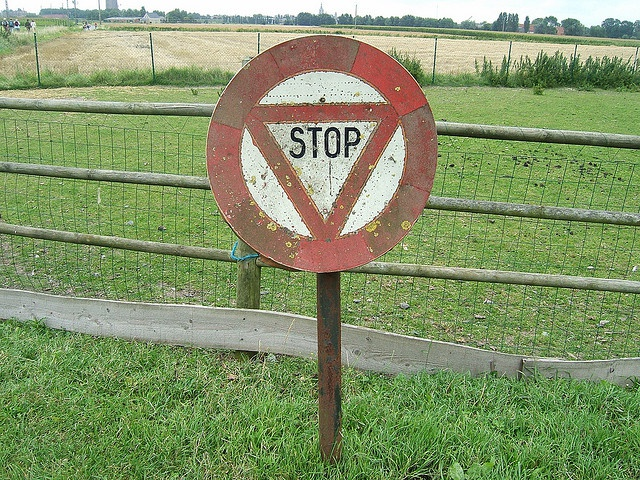Describe the objects in this image and their specific colors. I can see stop sign in white, brown, ivory, gray, and darkgray tones, people in white, darkgray, gray, and black tones, people in white, gray, darkgray, and teal tones, people in white, darkgray, gray, and lightgray tones, and people in white, ivory, darkgray, beige, and gray tones in this image. 